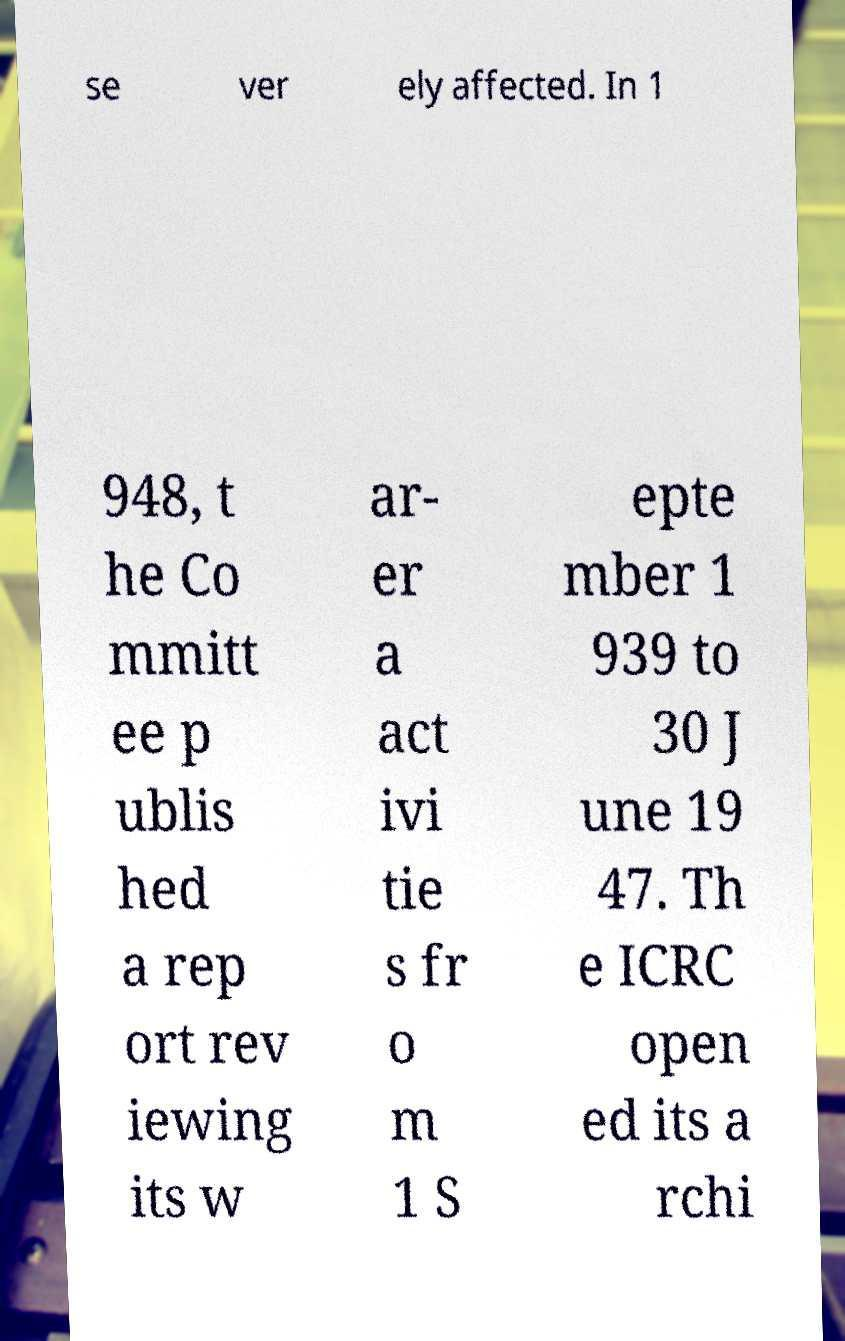Can you read and provide the text displayed in the image?This photo seems to have some interesting text. Can you extract and type it out for me? se ver ely affected. In 1 948, t he Co mmitt ee p ublis hed a rep ort rev iewing its w ar- er a act ivi tie s fr o m 1 S epte mber 1 939 to 30 J une 19 47. Th e ICRC open ed its a rchi 